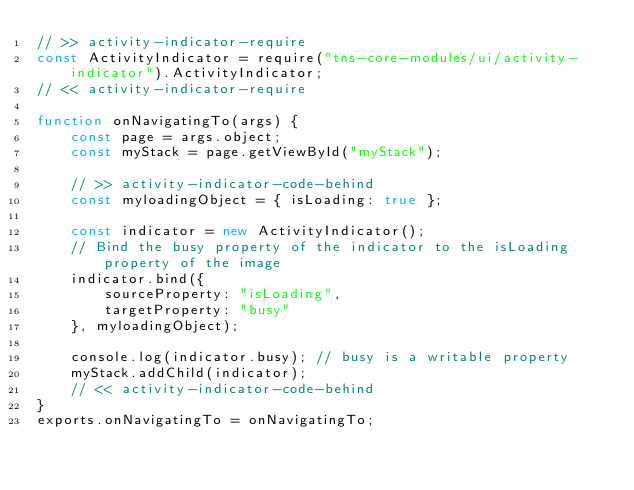Convert code to text. <code><loc_0><loc_0><loc_500><loc_500><_JavaScript_>// >> activity-indicator-require
const ActivityIndicator = require("tns-core-modules/ui/activity-indicator").ActivityIndicator;
// << activity-indicator-require

function onNavigatingTo(args) {
    const page = args.object;
    const myStack = page.getViewById("myStack");

    // >> activity-indicator-code-behind
    const myloadingObject = { isLoading: true };

    const indicator = new ActivityIndicator();
    // Bind the busy property of the indicator to the isLoading property of the image
    indicator.bind({
        sourceProperty: "isLoading",
        targetProperty: "busy"
    }, myloadingObject);

    console.log(indicator.busy); // busy is a writable property
    myStack.addChild(indicator);
    // << activity-indicator-code-behind
}
exports.onNavigatingTo = onNavigatingTo;
</code> 